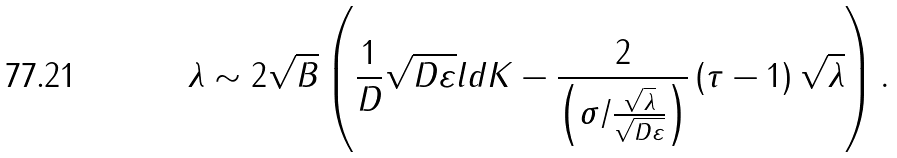<formula> <loc_0><loc_0><loc_500><loc_500>\lambda \sim 2 \sqrt { B } \left ( \frac { 1 } { D } \sqrt { D \varepsilon } l d K - \frac { 2 } { \left ( \sigma / \frac { \sqrt { \lambda } } { \sqrt { D \varepsilon } } \right ) } \left ( \tau - 1 \right ) \sqrt { \lambda } \right ) .</formula> 